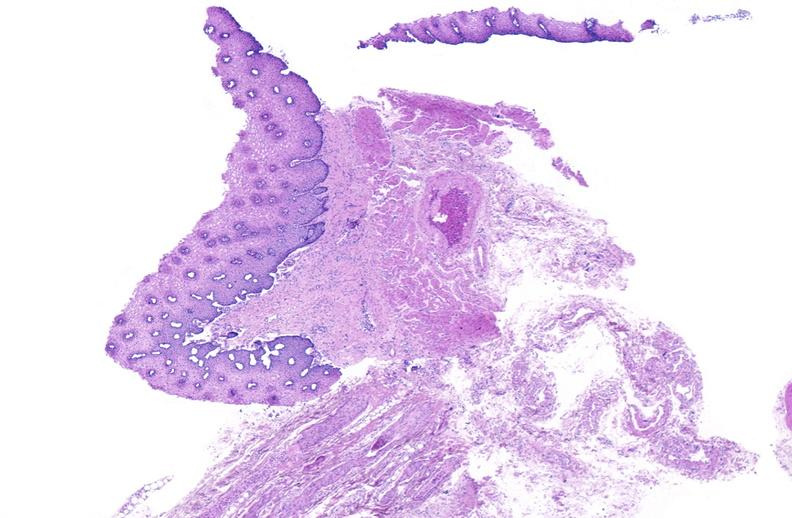does this image show esophagus, varices?
Answer the question using a single word or phrase. Yes 